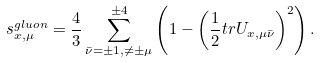Convert formula to latex. <formula><loc_0><loc_0><loc_500><loc_500>s ^ { g l u o n } _ { x , \mu } = \frac { 4 } { 3 } \sum _ { \bar { \nu } = \pm 1 , \ne \pm \mu } ^ { \pm 4 } \left ( 1 - \left ( \frac { 1 } { 2 } t r U _ { x , \mu \bar { \nu } } \right ) ^ { 2 } \right ) .</formula> 